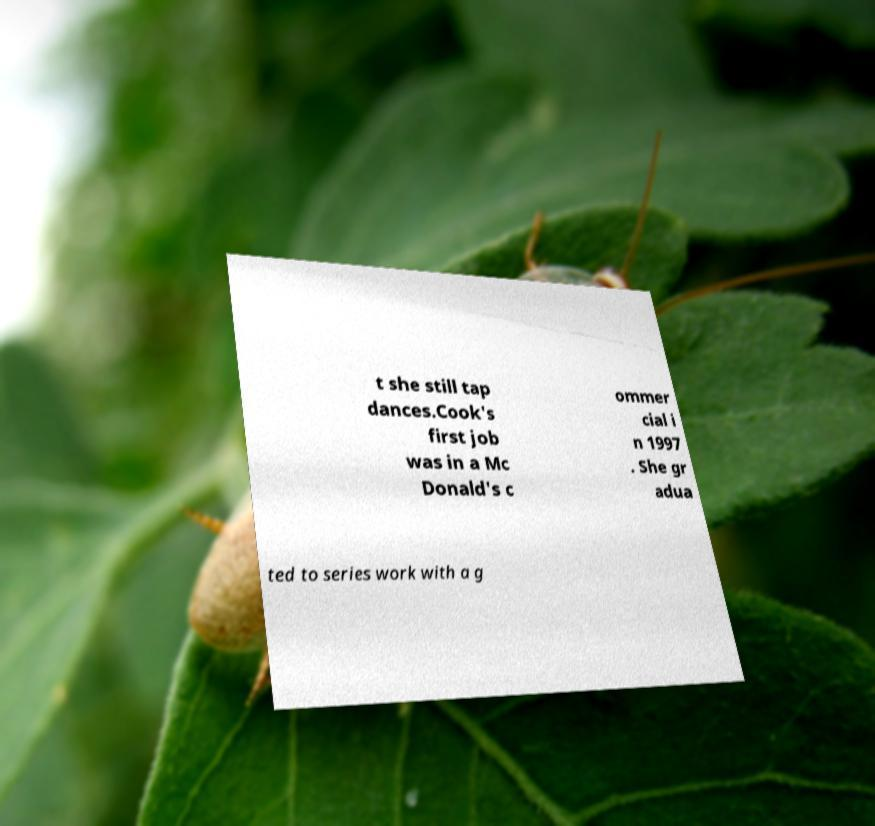Can you read and provide the text displayed in the image?This photo seems to have some interesting text. Can you extract and type it out for me? t she still tap dances.Cook's first job was in a Mc Donald's c ommer cial i n 1997 . She gr adua ted to series work with a g 